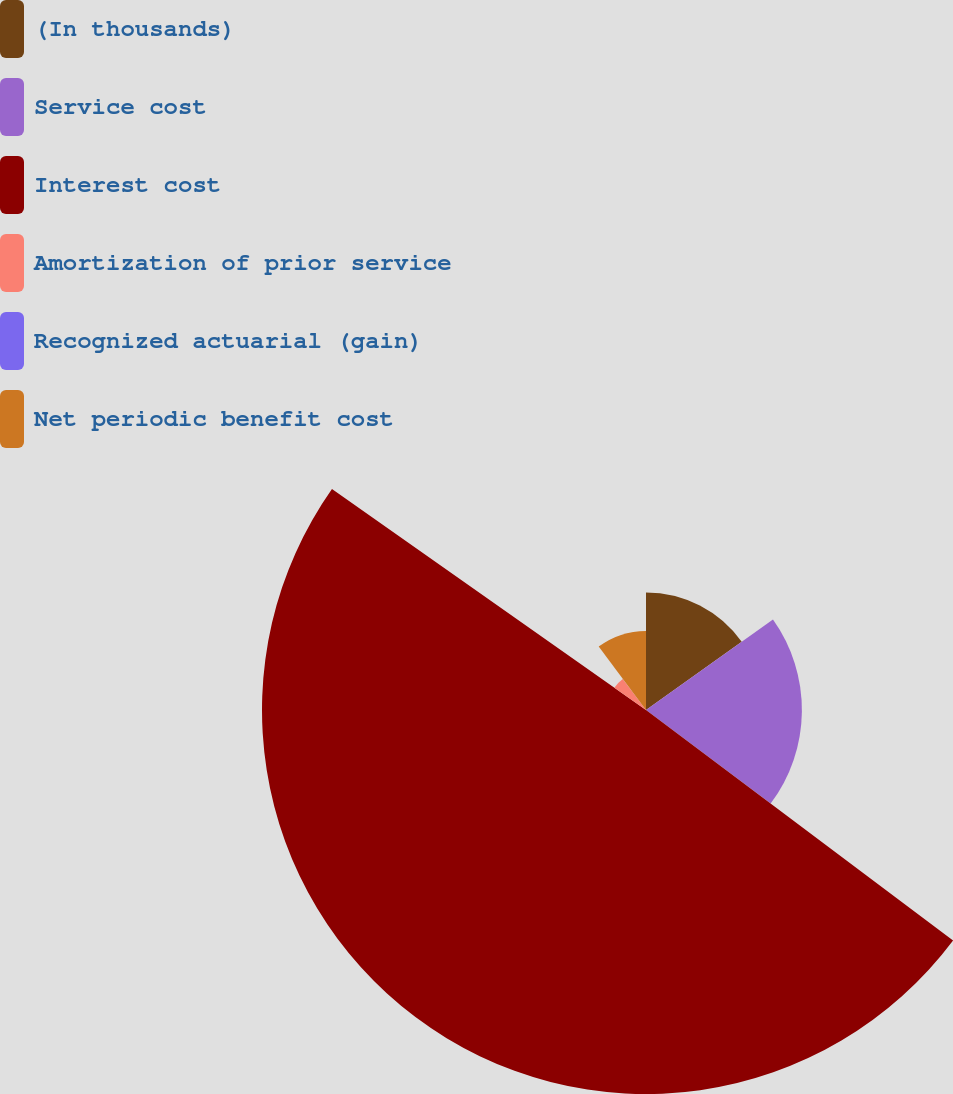Convert chart. <chart><loc_0><loc_0><loc_500><loc_500><pie_chart><fcel>(In thousands)<fcel>Service cost<fcel>Interest cost<fcel>Amortization of prior service<fcel>Recognized actuarial (gain)<fcel>Net periodic benefit cost<nl><fcel>15.15%<fcel>20.1%<fcel>49.51%<fcel>4.99%<fcel>0.05%<fcel>10.2%<nl></chart> 